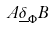Convert formula to latex. <formula><loc_0><loc_0><loc_500><loc_500>A \underline { \delta } _ { \Phi } B</formula> 